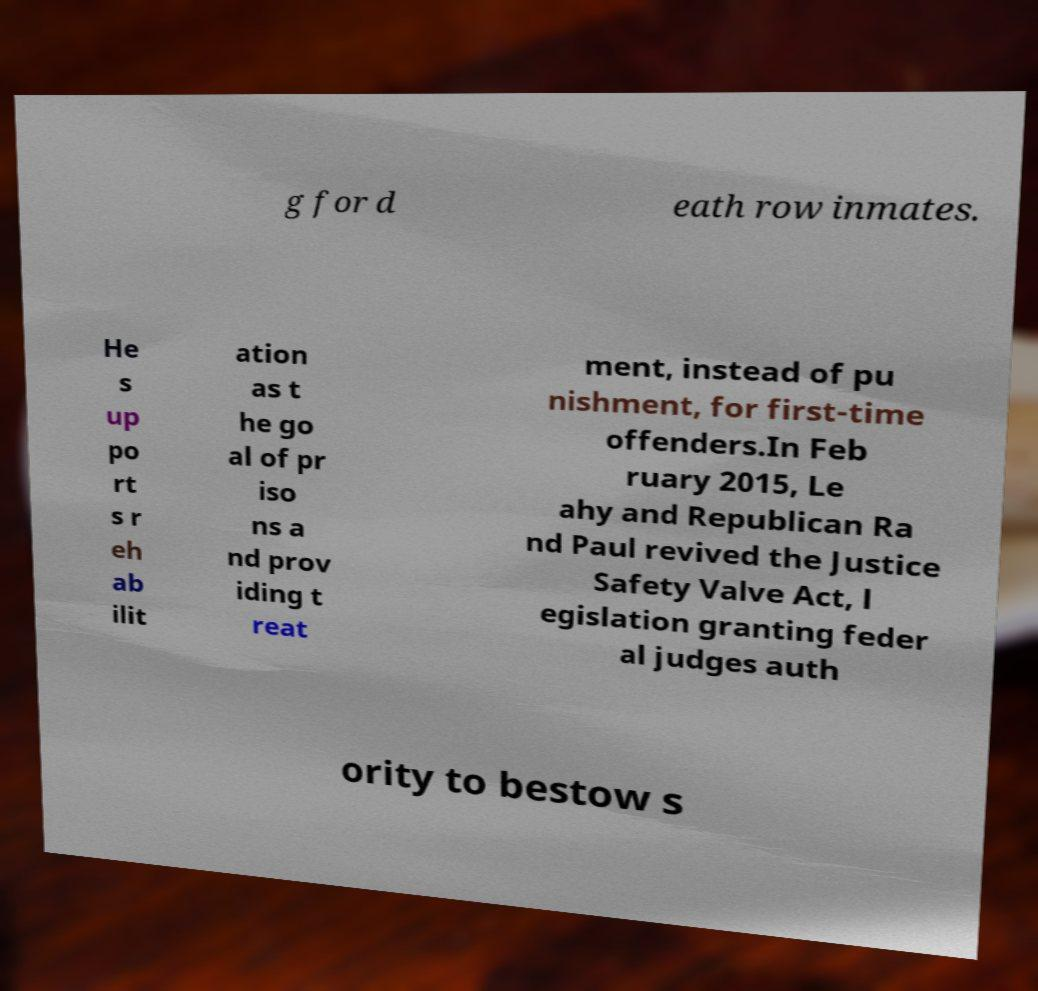Please identify and transcribe the text found in this image. g for d eath row inmates. He s up po rt s r eh ab ilit ation as t he go al of pr iso ns a nd prov iding t reat ment, instead of pu nishment, for first-time offenders.In Feb ruary 2015, Le ahy and Republican Ra nd Paul revived the Justice Safety Valve Act, l egislation granting feder al judges auth ority to bestow s 